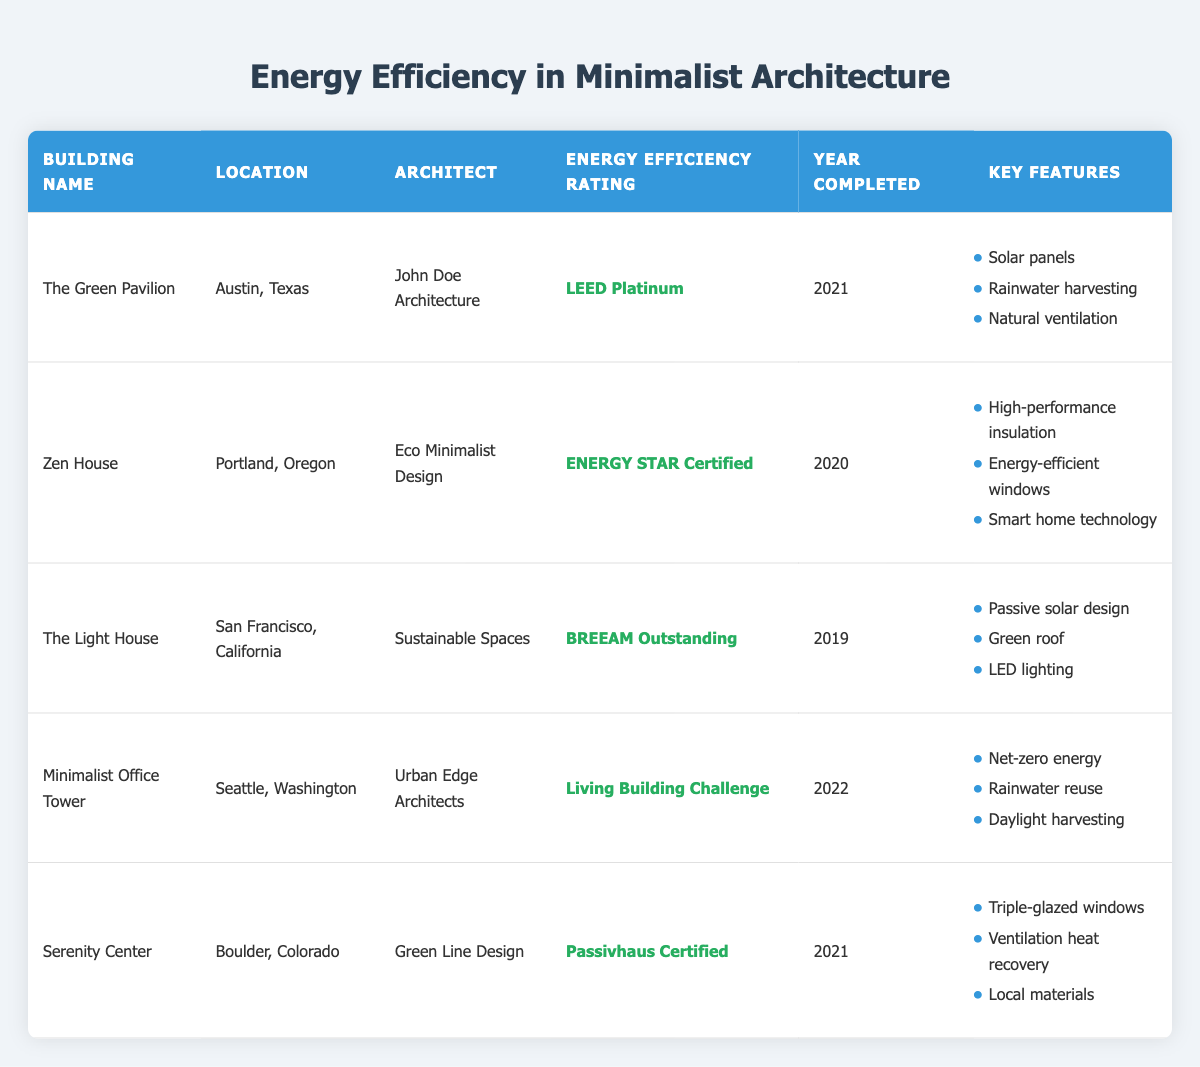What is the Energy Efficiency Rating of "The Green Pavilion"? The table specifically lists "The Green Pavilion" under the column "Energy Efficiency Rating," where it shows a rating of "LEED Platinum."
Answer: LEED Platinum Which building was completed more recently, the "Minimalist Office Tower" or the "Zen House"? The completion years for "Minimalist Office Tower" and "Zen House" are 2022 and 2020, respectively. Since 2022 is later than 2020, the "Minimalist Office Tower" was completed more recently.
Answer: Minimalist Office Tower How many buildings have a BREEAM rating? Referring to the table, there's only one building with a BREEAM rating, which is "The Light House," as it is annotated as "BREEAM Outstanding."
Answer: 1 What are the key features of the "Serenity Center"? The "Serenity Center" has a list of key features provided in the table: triple-glazed windows, ventilation heat recovery, and local materials.
Answer: Triple-glazed windows, ventilation heat recovery, local materials Is the "Green Pavilion" designed by an architect from Austin? The table lists "The Green Pavilion" and states its architect is "John Doe Architecture," located in Austin, Texas, indicating a local architect as the term "from Austin" typically implies.
Answer: Yes What is the average year of completion for the listed buildings? The completion years are 2021, 2020, 2019, 2022, and 2021. To find the average: (2021 + 2020 + 2019 + 2022 + 2021) = 10104, and there are 5 buildings, so 10104 / 5 = 2020.8. Rounded down gives an average year of 2021.
Answer: 2021 Which energy efficiency rating appears most frequently in the table? Upon reviewing the energy efficiency ratings, LEED Platinum, ENERGY STAR Certified, BREEAM Outstanding, Living Building Challenge, and Passivhaus Certified occurrences show each is unique, thus there are no repeating ratings.
Answer: None Which building has the most energy efficiency rating classifications? Each building has a unique energy efficiency rating with no overlaps. Thus, there is no building with more than one classification or rating.
Answer: None 